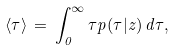Convert formula to latex. <formula><loc_0><loc_0><loc_500><loc_500>\langle \tau \rangle \, = \, \int ^ { \infty } _ { 0 } \tau p ( \tau | z ) \, d \tau ,</formula> 